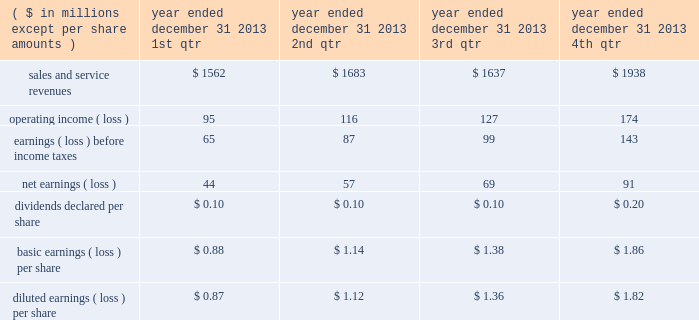"three factor formula" ) .
The consolidated financial statements include northrop grumman management and support services allocations totaling $ 32 million for the year ended december 31 , 2011 .
Shared services and infrastructure costs - this category includes costs for functions such as information technology support , systems maintenance , telecommunications , procurement and other shared services while hii was a subsidiary of northrop grumman .
These costs were generally allocated to the company using the three factor formula or based on usage .
The consolidated financial statements reflect shared services and infrastructure costs allocations totaling $ 80 million for the year ended december 31 , 2011 .
Northrop grumman-provided benefits - this category includes costs for group medical , dental and vision insurance , 401 ( k ) savings plan , pension and postretirement benefits , incentive compensation and other benefits .
These costs were generally allocated to the company based on specific identification of the benefits provided to company employees participating in these benefit plans .
The consolidated financial statements include northrop grumman- provided benefits allocations totaling $ 169 million for the year ended december 31 , 2011 .
Management believes that the methods of allocating these costs are reasonable , consistent with past practices , and in conformity with cost allocation requirements of cas or the far .
Related party sales and cost of sales prior to the spin-off , hii purchased and sold certain products and services from and to other northrop grumman entities .
Purchases of products and services from these affiliated entities , which were recorded at cost , were $ 44 million for the year ended december 31 , 2011 .
Sales of products and services to these entities were $ 1 million for the year ended december 31 , 2011 .
Former parent's equity in unit transactions between hii and northrop grumman prior to the spin-off have been included in the consolidated financial statements and were effectively settled for cash at the time the transaction was recorded .
The net effect of the settlement of these transactions is reflected as former parent's equity in unit in the consolidated statement of changes in equity .
21 .
Unaudited selected quarterly data unaudited quarterly financial results for the years ended december 31 , 2013 and 2012 , are set forth in the tables: .

What is the total dividend per share declared in 2013? 
Computations: (((0.10 + 0.10) + 0.10) + (0.10 + 0.10))
Answer: 0.5. 